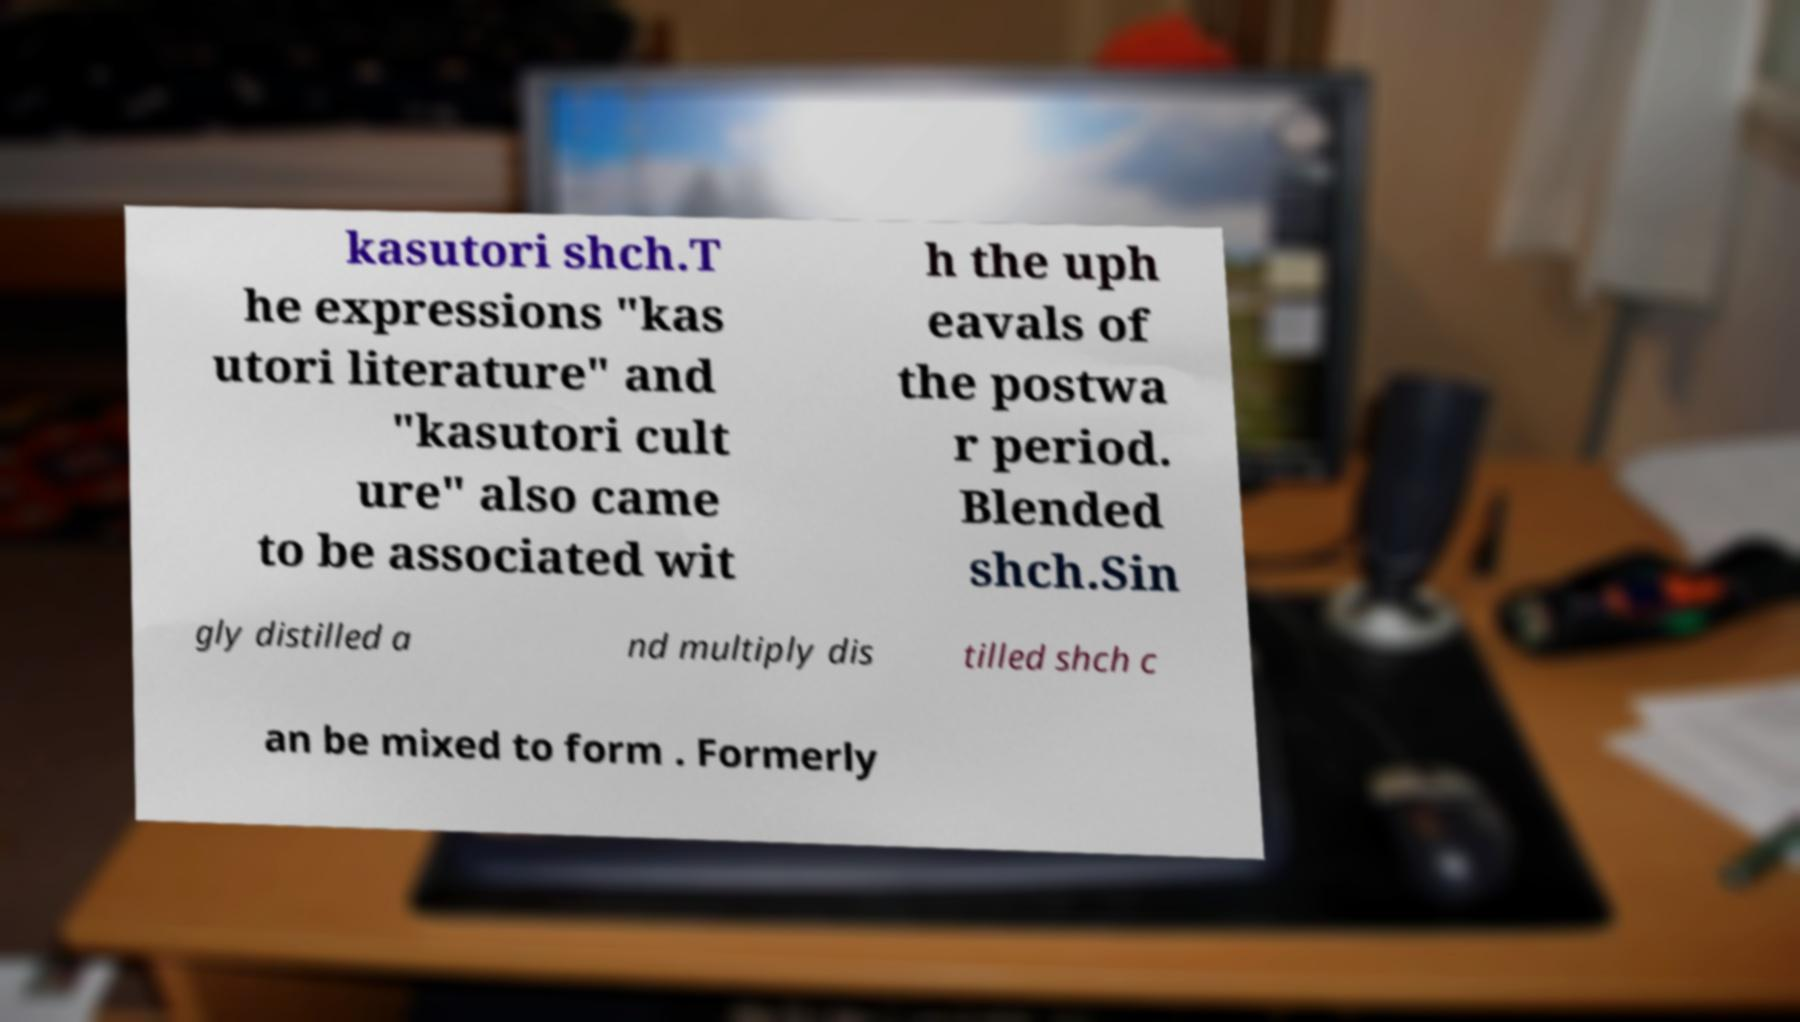Could you extract and type out the text from this image? kasutori shch.T he expressions "kas utori literature" and "kasutori cult ure" also came to be associated wit h the uph eavals of the postwa r period. Blended shch.Sin gly distilled a nd multiply dis tilled shch c an be mixed to form . Formerly 